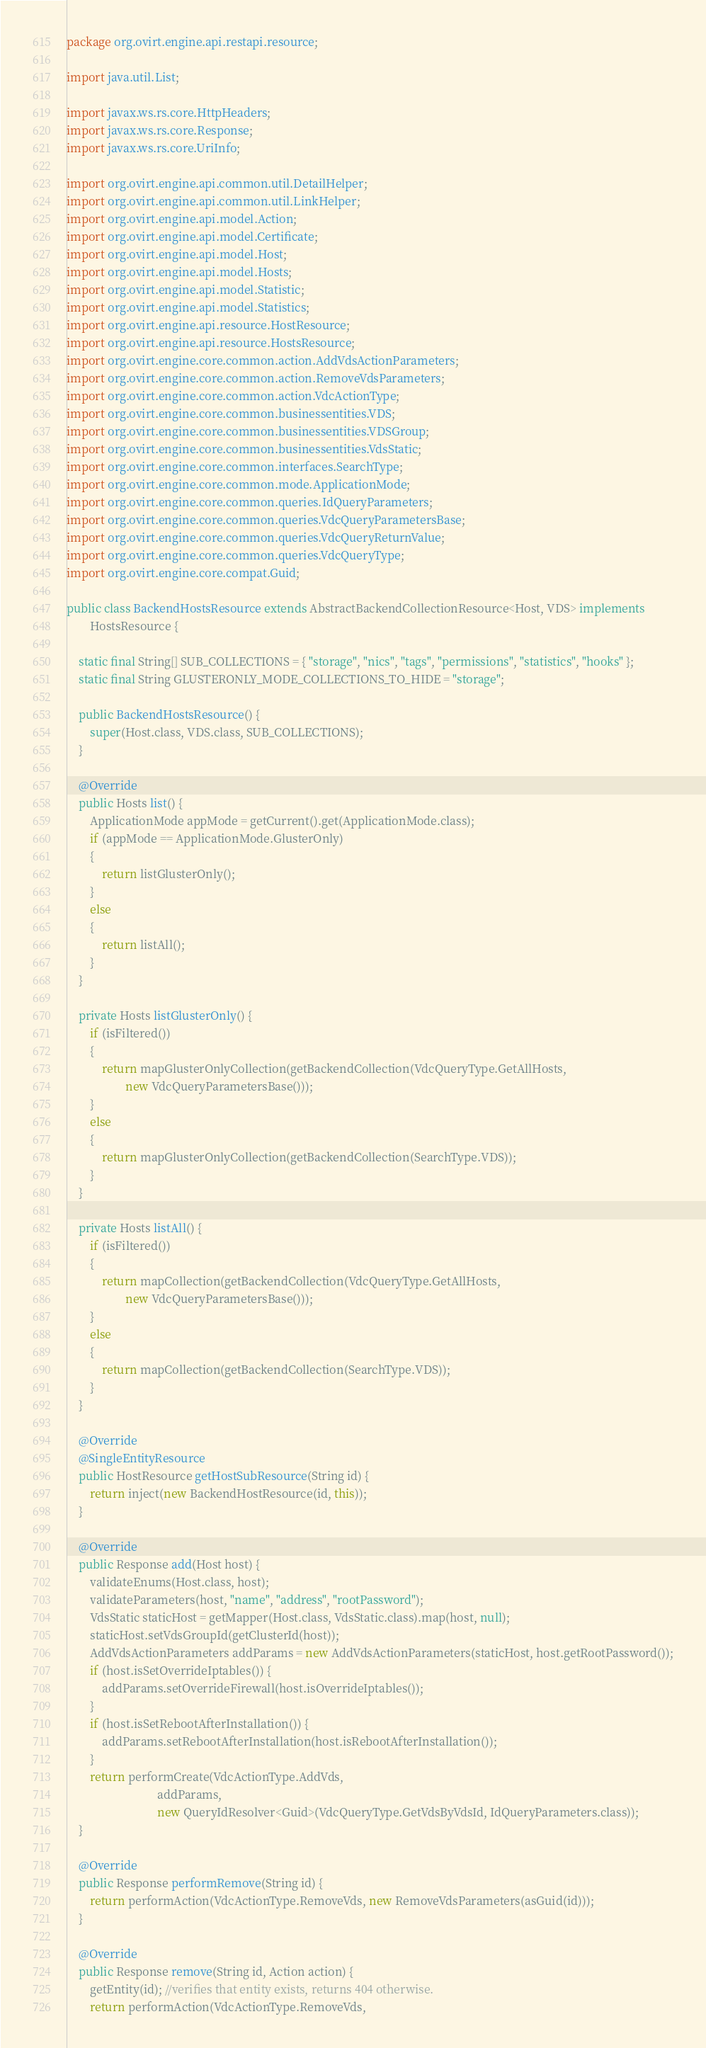<code> <loc_0><loc_0><loc_500><loc_500><_Java_>package org.ovirt.engine.api.restapi.resource;

import java.util.List;

import javax.ws.rs.core.HttpHeaders;
import javax.ws.rs.core.Response;
import javax.ws.rs.core.UriInfo;

import org.ovirt.engine.api.common.util.DetailHelper;
import org.ovirt.engine.api.common.util.LinkHelper;
import org.ovirt.engine.api.model.Action;
import org.ovirt.engine.api.model.Certificate;
import org.ovirt.engine.api.model.Host;
import org.ovirt.engine.api.model.Hosts;
import org.ovirt.engine.api.model.Statistic;
import org.ovirt.engine.api.model.Statistics;
import org.ovirt.engine.api.resource.HostResource;
import org.ovirt.engine.api.resource.HostsResource;
import org.ovirt.engine.core.common.action.AddVdsActionParameters;
import org.ovirt.engine.core.common.action.RemoveVdsParameters;
import org.ovirt.engine.core.common.action.VdcActionType;
import org.ovirt.engine.core.common.businessentities.VDS;
import org.ovirt.engine.core.common.businessentities.VDSGroup;
import org.ovirt.engine.core.common.businessentities.VdsStatic;
import org.ovirt.engine.core.common.interfaces.SearchType;
import org.ovirt.engine.core.common.mode.ApplicationMode;
import org.ovirt.engine.core.common.queries.IdQueryParameters;
import org.ovirt.engine.core.common.queries.VdcQueryParametersBase;
import org.ovirt.engine.core.common.queries.VdcQueryReturnValue;
import org.ovirt.engine.core.common.queries.VdcQueryType;
import org.ovirt.engine.core.compat.Guid;

public class BackendHostsResource extends AbstractBackendCollectionResource<Host, VDS> implements
        HostsResource {

    static final String[] SUB_COLLECTIONS = { "storage", "nics", "tags", "permissions", "statistics", "hooks" };
    static final String GLUSTERONLY_MODE_COLLECTIONS_TO_HIDE = "storage";

    public BackendHostsResource() {
        super(Host.class, VDS.class, SUB_COLLECTIONS);
    }

    @Override
    public Hosts list() {
        ApplicationMode appMode = getCurrent().get(ApplicationMode.class);
        if (appMode == ApplicationMode.GlusterOnly)
        {
            return listGlusterOnly();
        }
        else
        {
            return listAll();
        }
    }

    private Hosts listGlusterOnly() {
        if (isFiltered())
        {
            return mapGlusterOnlyCollection(getBackendCollection(VdcQueryType.GetAllHosts,
                    new VdcQueryParametersBase()));
        }
        else
        {
            return mapGlusterOnlyCollection(getBackendCollection(SearchType.VDS));
        }
    }

    private Hosts listAll() {
        if (isFiltered())
        {
            return mapCollection(getBackendCollection(VdcQueryType.GetAllHosts,
                    new VdcQueryParametersBase()));
        }
        else
        {
            return mapCollection(getBackendCollection(SearchType.VDS));
        }
    }

    @Override
    @SingleEntityResource
    public HostResource getHostSubResource(String id) {
        return inject(new BackendHostResource(id, this));
    }

    @Override
    public Response add(Host host) {
        validateEnums(Host.class, host);
        validateParameters(host, "name", "address", "rootPassword");
        VdsStatic staticHost = getMapper(Host.class, VdsStatic.class).map(host, null);
        staticHost.setVdsGroupId(getClusterId(host));
        AddVdsActionParameters addParams = new AddVdsActionParameters(staticHost, host.getRootPassword());
        if (host.isSetOverrideIptables()) {
            addParams.setOverrideFirewall(host.isOverrideIptables());
        }
        if (host.isSetRebootAfterInstallation()) {
            addParams.setRebootAfterInstallation(host.isRebootAfterInstallation());
        }
        return performCreate(VdcActionType.AddVds,
                               addParams,
                               new QueryIdResolver<Guid>(VdcQueryType.GetVdsByVdsId, IdQueryParameters.class));
    }

    @Override
    public Response performRemove(String id) {
        return performAction(VdcActionType.RemoveVds, new RemoveVdsParameters(asGuid(id)));
    }

    @Override
    public Response remove(String id, Action action) {
        getEntity(id); //verifies that entity exists, returns 404 otherwise.
        return performAction(VdcActionType.RemoveVds,</code> 